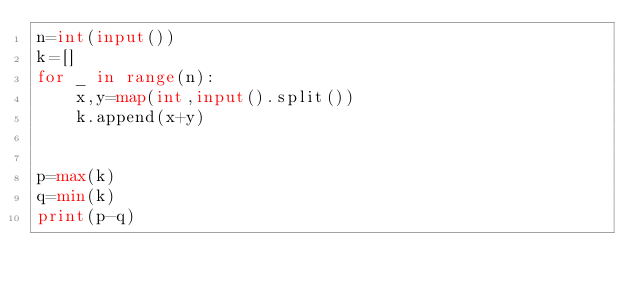Convert code to text. <code><loc_0><loc_0><loc_500><loc_500><_Python_>n=int(input())
k=[]
for _ in range(n):
    x,y=map(int,input().split())
    k.append(x+y)


p=max(k)
q=min(k)
print(p-q)
</code> 